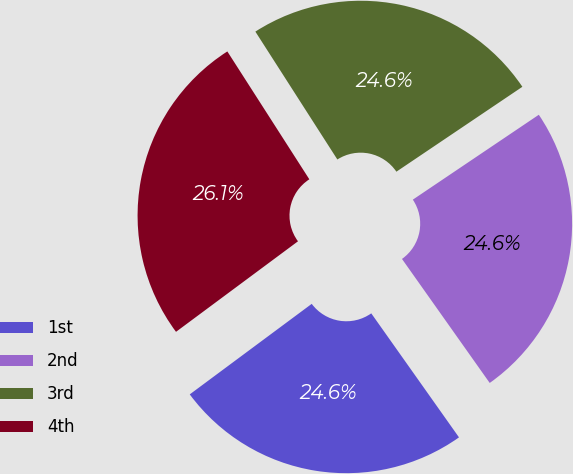Convert chart to OTSL. <chart><loc_0><loc_0><loc_500><loc_500><pie_chart><fcel>1st<fcel>2nd<fcel>3rd<fcel>4th<nl><fcel>24.64%<fcel>24.64%<fcel>24.64%<fcel>26.09%<nl></chart> 